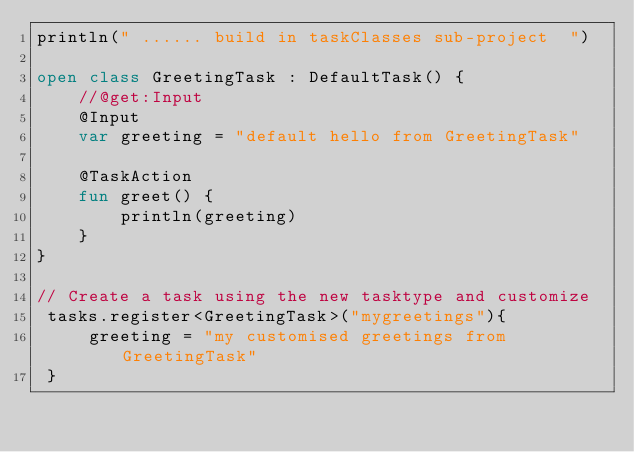Convert code to text. <code><loc_0><loc_0><loc_500><loc_500><_Kotlin_>println(" ...... build in taskClasses sub-project  ")

open class GreetingTask : DefaultTask() {
    //@get:Input
    @Input
    var greeting = "default hello from GreetingTask"

    @TaskAction
    fun greet() {
        println(greeting)
    }
}

// Create a task using the new tasktype and customize
 tasks.register<GreetingTask>("mygreetings"){
     greeting = "my customised greetings from GreetingTask"
 }</code> 